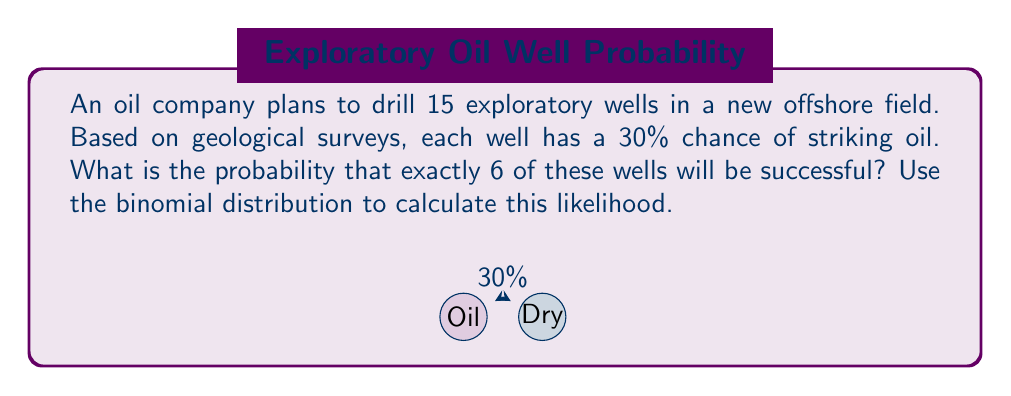What is the answer to this math problem? To solve this problem, we'll use the binomial distribution formula:

$$P(X = k) = \binom{n}{k} p^k (1-p)^{n-k}$$

Where:
$n$ = number of trials (wells drilled) = 15
$k$ = number of successes (successful wells) = 6
$p$ = probability of success for each trial = 0.30

Step 1: Calculate the binomial coefficient $\binom{n}{k}$
$$\binom{15}{6} = \frac{15!}{6!(15-6)!} = \frac{15!}{6!9!} = 5005$$

Step 2: Calculate $p^k$
$$0.30^6 = 0.000729$$

Step 3: Calculate $(1-p)^{n-k}$
$$(1-0.30)^{15-6} = 0.70^9 = 0.040353$$

Step 4: Multiply the results from steps 1, 2, and 3
$$5005 \times 0.000729 \times 0.040353 = 0.147172$$

Therefore, the probability of exactly 6 successful wells out of 15 attempts is approximately 0.147172 or 14.72%.
Answer: 0.147172 